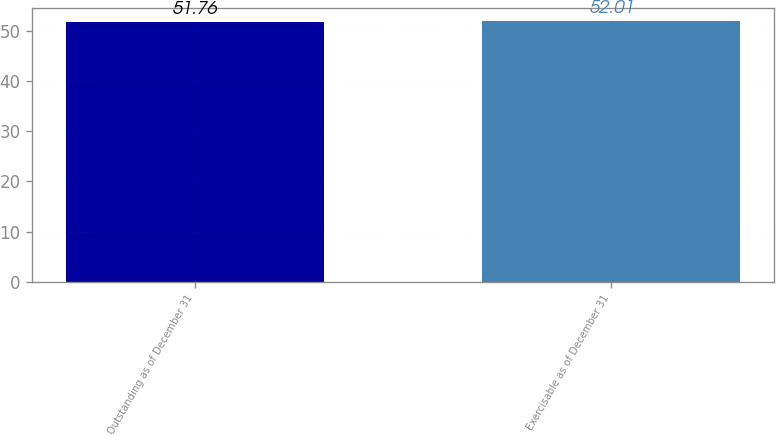Convert chart. <chart><loc_0><loc_0><loc_500><loc_500><bar_chart><fcel>Outstanding as of December 31<fcel>Exercisable as of December 31<nl><fcel>51.76<fcel>52.01<nl></chart> 